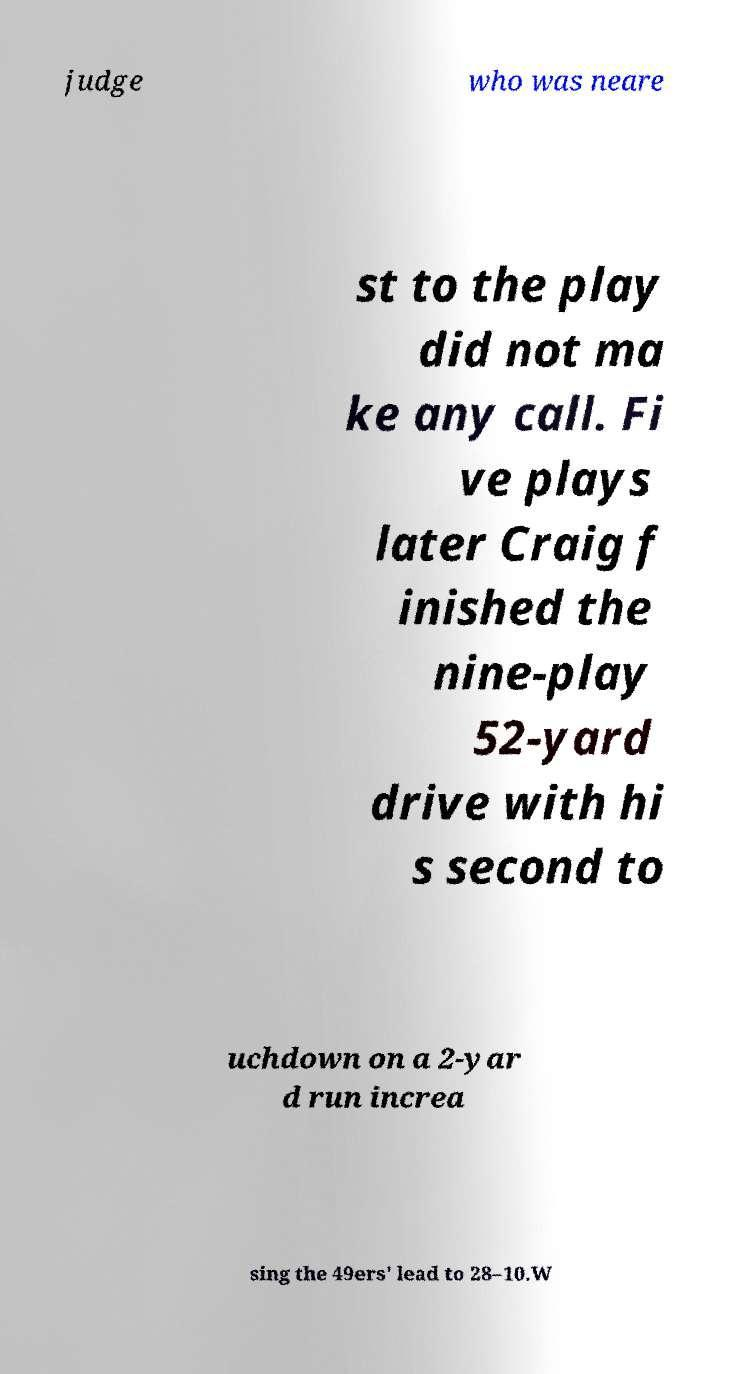What messages or text are displayed in this image? I need them in a readable, typed format. judge who was neare st to the play did not ma ke any call. Fi ve plays later Craig f inished the nine-play 52-yard drive with hi s second to uchdown on a 2-yar d run increa sing the 49ers' lead to 28–10.W 